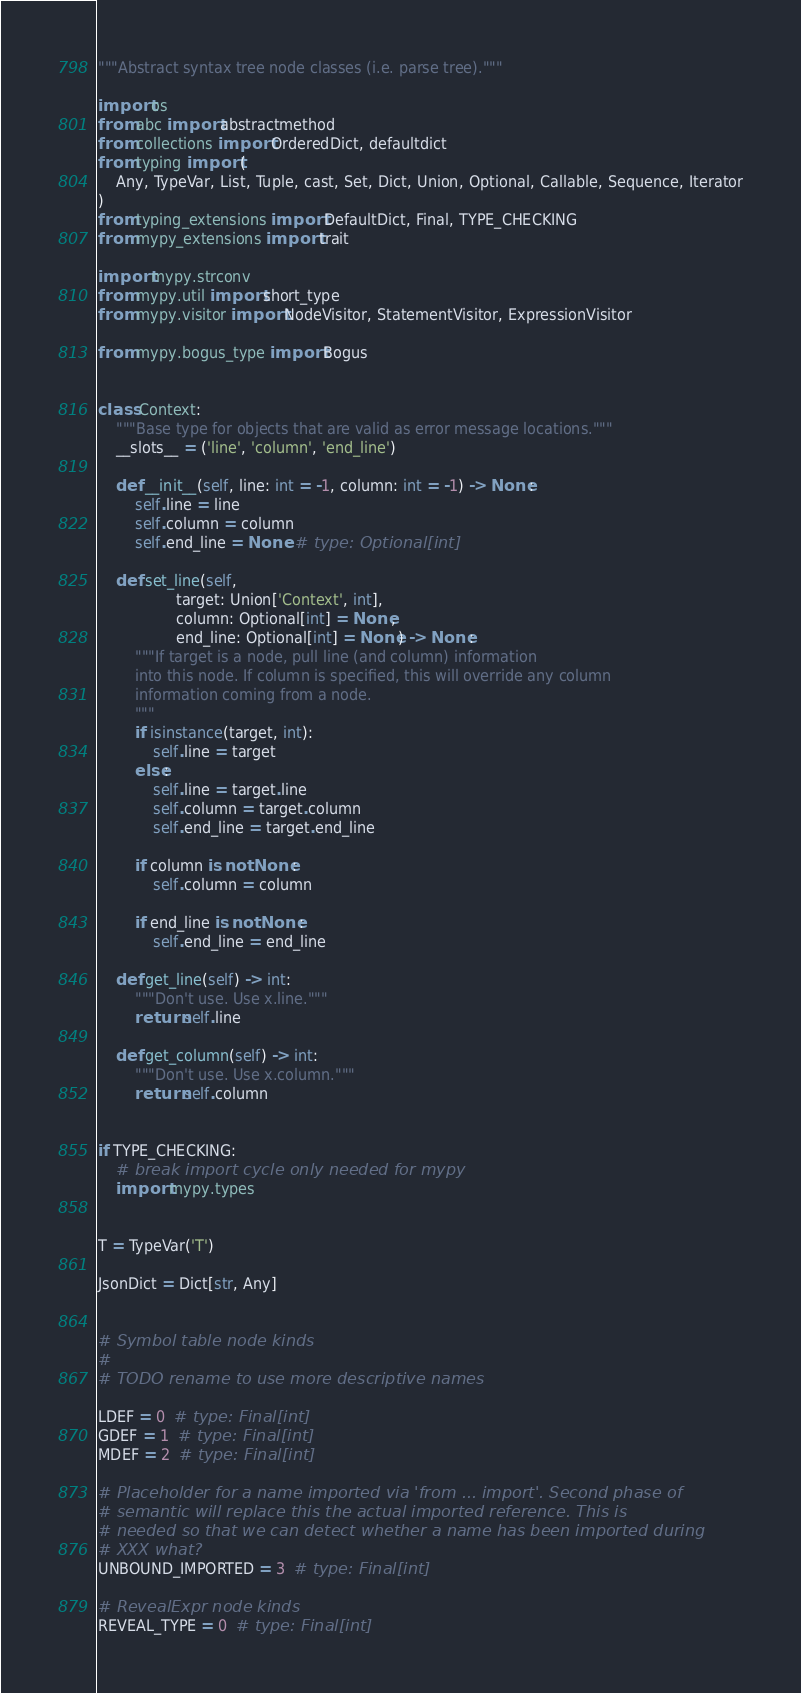<code> <loc_0><loc_0><loc_500><loc_500><_Python_>"""Abstract syntax tree node classes (i.e. parse tree)."""

import os
from abc import abstractmethod
from collections import OrderedDict, defaultdict
from typing import (
    Any, TypeVar, List, Tuple, cast, Set, Dict, Union, Optional, Callable, Sequence, Iterator
)
from typing_extensions import DefaultDict, Final, TYPE_CHECKING
from mypy_extensions import trait

import mypy.strconv
from mypy.util import short_type
from mypy.visitor import NodeVisitor, StatementVisitor, ExpressionVisitor

from mypy.bogus_type import Bogus


class Context:
    """Base type for objects that are valid as error message locations."""
    __slots__ = ('line', 'column', 'end_line')

    def __init__(self, line: int = -1, column: int = -1) -> None:
        self.line = line
        self.column = column
        self.end_line = None  # type: Optional[int]

    def set_line(self,
                 target: Union['Context', int],
                 column: Optional[int] = None,
                 end_line: Optional[int] = None) -> None:
        """If target is a node, pull line (and column) information
        into this node. If column is specified, this will override any column
        information coming from a node.
        """
        if isinstance(target, int):
            self.line = target
        else:
            self.line = target.line
            self.column = target.column
            self.end_line = target.end_line

        if column is not None:
            self.column = column

        if end_line is not None:
            self.end_line = end_line

    def get_line(self) -> int:
        """Don't use. Use x.line."""
        return self.line

    def get_column(self) -> int:
        """Don't use. Use x.column."""
        return self.column


if TYPE_CHECKING:
    # break import cycle only needed for mypy
    import mypy.types


T = TypeVar('T')

JsonDict = Dict[str, Any]


# Symbol table node kinds
#
# TODO rename to use more descriptive names

LDEF = 0  # type: Final[int]
GDEF = 1  # type: Final[int]
MDEF = 2  # type: Final[int]

# Placeholder for a name imported via 'from ... import'. Second phase of
# semantic will replace this the actual imported reference. This is
# needed so that we can detect whether a name has been imported during
# XXX what?
UNBOUND_IMPORTED = 3  # type: Final[int]

# RevealExpr node kinds
REVEAL_TYPE = 0  # type: Final[int]</code> 